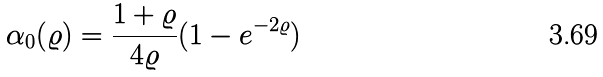Convert formula to latex. <formula><loc_0><loc_0><loc_500><loc_500>\alpha _ { 0 } ( \varrho ) = \frac { 1 + \varrho } { 4 \varrho } ( 1 - e ^ { - 2 \varrho } )</formula> 